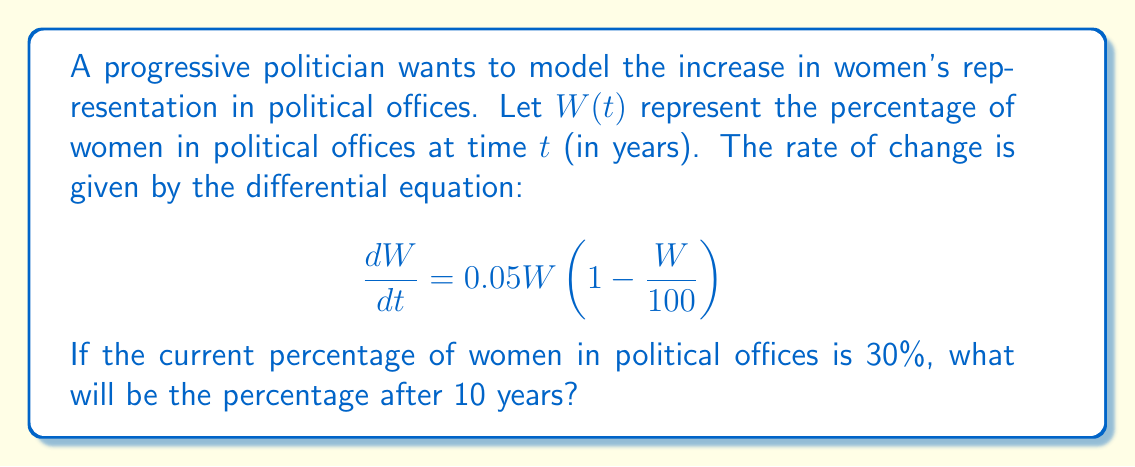Solve this math problem. To solve this problem, we need to use the logistic growth model, which is represented by the given differential equation. Let's approach this step-by-step:

1) The given differential equation is:

   $$\frac{dW}{dt} = 0.05W(1 - \frac{W}{100})$$

2) This is a separable differential equation. The solution to this equation is:

   $$W(t) = \frac{100}{1 + Ce^{-0.05t}}$$

   where $C$ is a constant that depends on the initial condition.

3) We're given that the current percentage (at $t=0$) is 30%. Let's use this to find $C$:

   $$30 = \frac{100}{1 + C}$$

4) Solving for $C$:

   $$C = \frac{100}{30} - 1 = \frac{10}{3} \approx 3.33$$

5) Now we have our full equation:

   $$W(t) = \frac{100}{1 + \frac{10}{3}e^{-0.05t}}$$

6) To find the percentage after 10 years, we plug in $t=10$:

   $$W(10) = \frac{100}{1 + \frac{10}{3}e^{-0.5}}$$

7) Calculating this:

   $$W(10) \approx 44.63$$

Therefore, after 10 years, the percentage of women in political offices will be approximately 44.63%.
Answer: 44.63% 